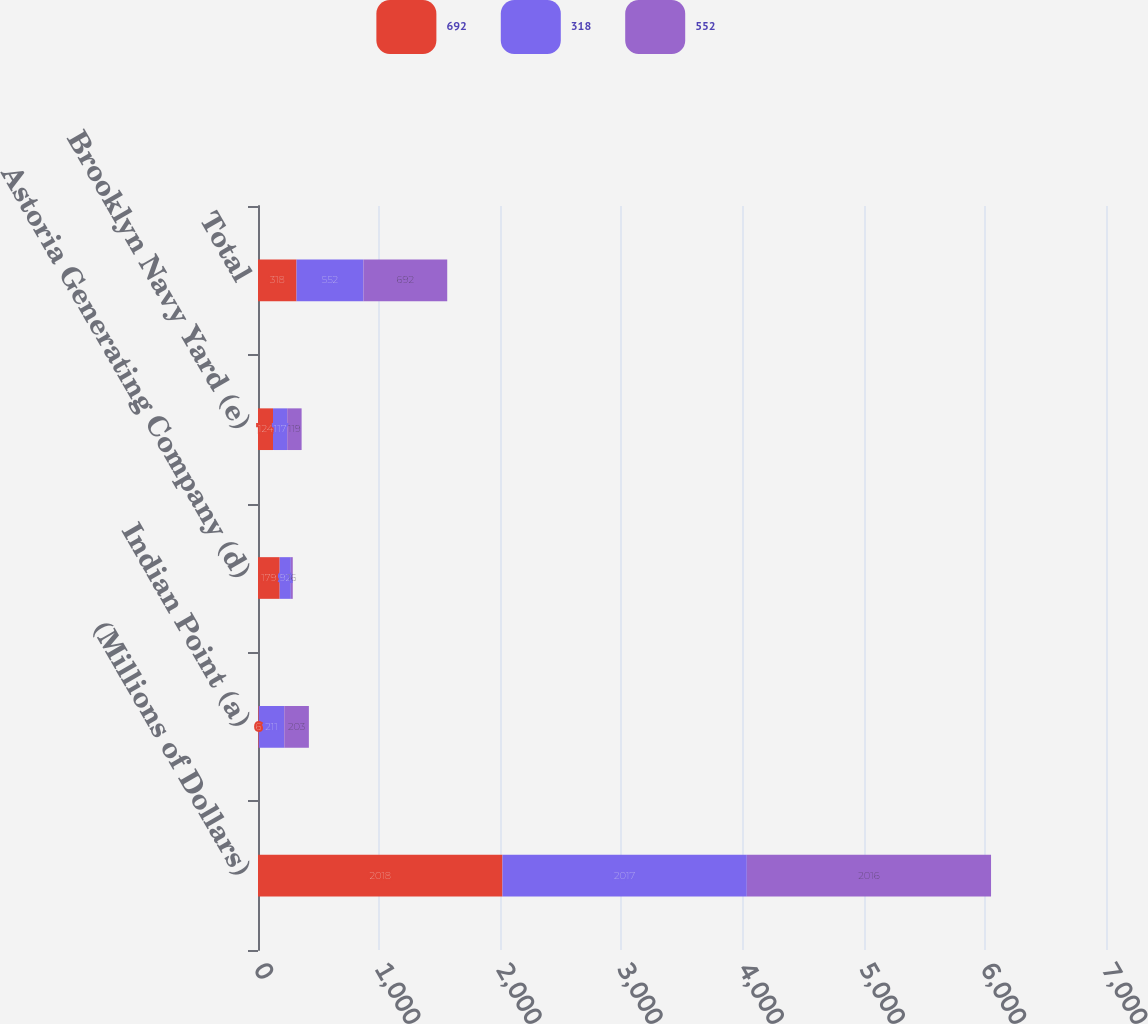Convert chart. <chart><loc_0><loc_0><loc_500><loc_500><stacked_bar_chart><ecel><fcel>(Millions of Dollars)<fcel>Indian Point (a)<fcel>Astoria Generating Company (d)<fcel>Brooklyn Navy Yard (e)<fcel>Total<nl><fcel>692<fcel>2018<fcel>6<fcel>179<fcel>124<fcel>318<nl><fcel>318<fcel>2017<fcel>211<fcel>92<fcel>117<fcel>552<nl><fcel>552<fcel>2016<fcel>203<fcel>16<fcel>119<fcel>692<nl></chart> 